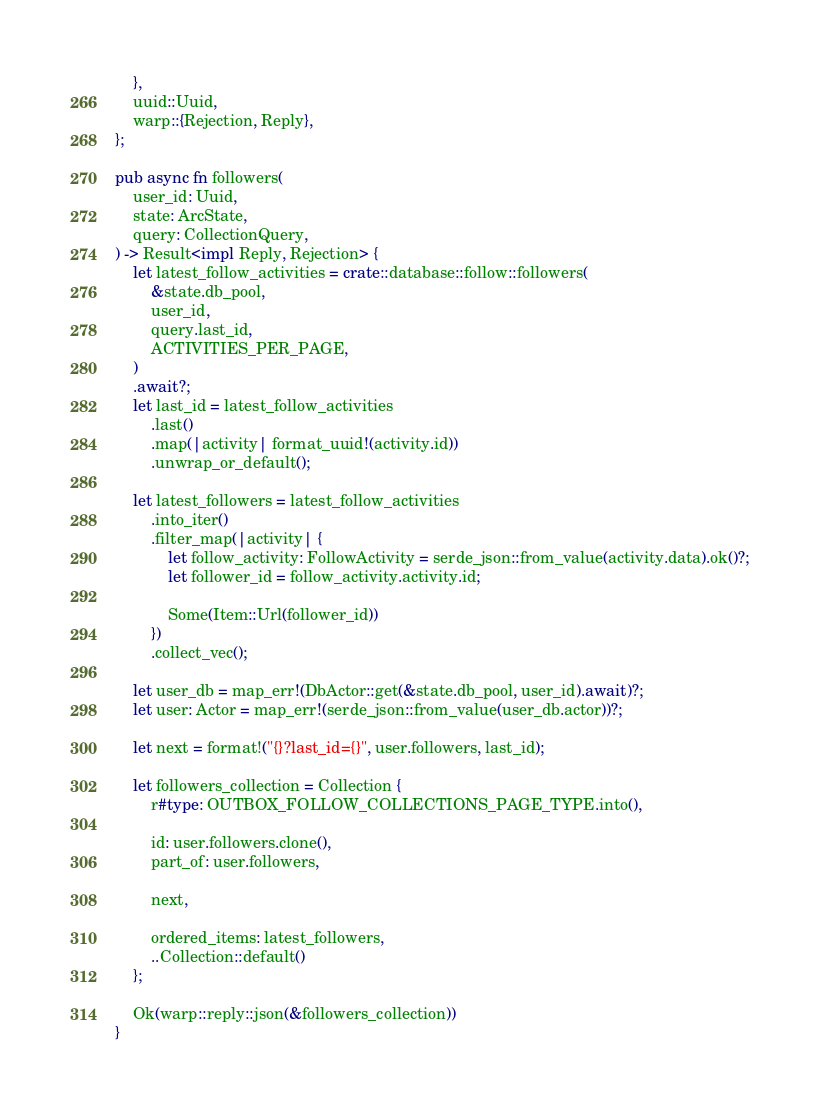Convert code to text. <code><loc_0><loc_0><loc_500><loc_500><_Rust_>    },
    uuid::Uuid,
    warp::{Rejection, Reply},
};

pub async fn followers(
    user_id: Uuid,
    state: ArcState,
    query: CollectionQuery,
) -> Result<impl Reply, Rejection> {
    let latest_follow_activities = crate::database::follow::followers(
        &state.db_pool,
        user_id,
        query.last_id,
        ACTIVITIES_PER_PAGE,
    )
    .await?;
    let last_id = latest_follow_activities
        .last()
        .map(|activity| format_uuid!(activity.id))
        .unwrap_or_default();

    let latest_followers = latest_follow_activities
        .into_iter()
        .filter_map(|activity| {
            let follow_activity: FollowActivity = serde_json::from_value(activity.data).ok()?;
            let follower_id = follow_activity.activity.id;

            Some(Item::Url(follower_id))
        })
        .collect_vec();

    let user_db = map_err!(DbActor::get(&state.db_pool, user_id).await)?;
    let user: Actor = map_err!(serde_json::from_value(user_db.actor))?;

    let next = format!("{}?last_id={}", user.followers, last_id);

    let followers_collection = Collection {
        r#type: OUTBOX_FOLLOW_COLLECTIONS_PAGE_TYPE.into(),

        id: user.followers.clone(),
        part_of: user.followers,

        next,

        ordered_items: latest_followers,
        ..Collection::default()
    };

    Ok(warp::reply::json(&followers_collection))
}
</code> 